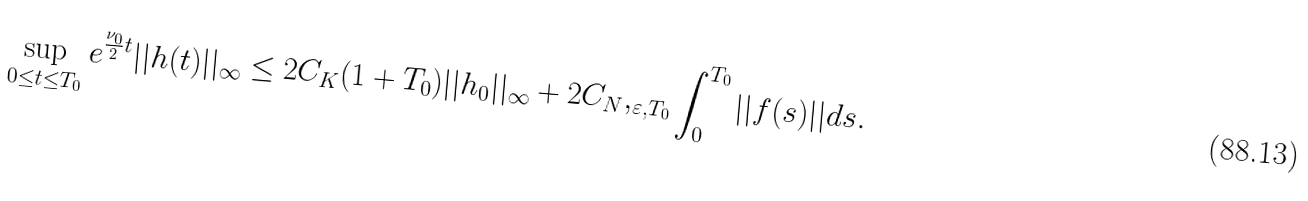Convert formula to latex. <formula><loc_0><loc_0><loc_500><loc_500>\sup _ { 0 \leq t \leq T _ { 0 } } e ^ { \frac { \nu _ { 0 } } { 2 } t } | | h ( t ) | | _ { \infty } \leq 2 C _ { K } ( 1 + T _ { 0 } ) | | h _ { 0 } | | _ { \infty } + 2 C _ { N } , _ { \varepsilon , T _ { 0 } } \int _ { 0 } ^ { T _ { 0 } } | | f ( s ) | | d s .</formula> 